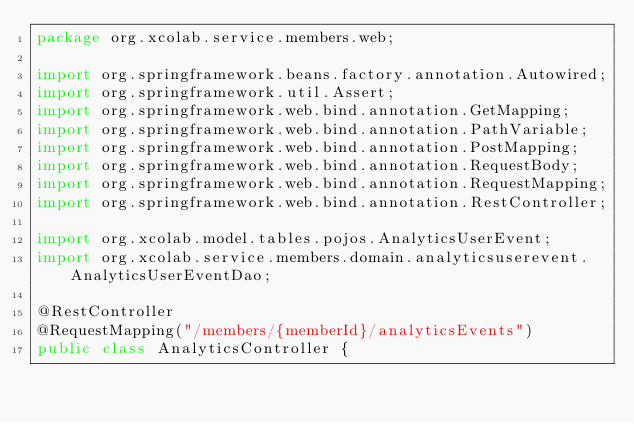Convert code to text. <code><loc_0><loc_0><loc_500><loc_500><_Java_>package org.xcolab.service.members.web;

import org.springframework.beans.factory.annotation.Autowired;
import org.springframework.util.Assert;
import org.springframework.web.bind.annotation.GetMapping;
import org.springframework.web.bind.annotation.PathVariable;
import org.springframework.web.bind.annotation.PostMapping;
import org.springframework.web.bind.annotation.RequestBody;
import org.springframework.web.bind.annotation.RequestMapping;
import org.springframework.web.bind.annotation.RestController;

import org.xcolab.model.tables.pojos.AnalyticsUserEvent;
import org.xcolab.service.members.domain.analyticsuserevent.AnalyticsUserEventDao;

@RestController
@RequestMapping("/members/{memberId}/analyticsEvents")
public class AnalyticsController {
</code> 